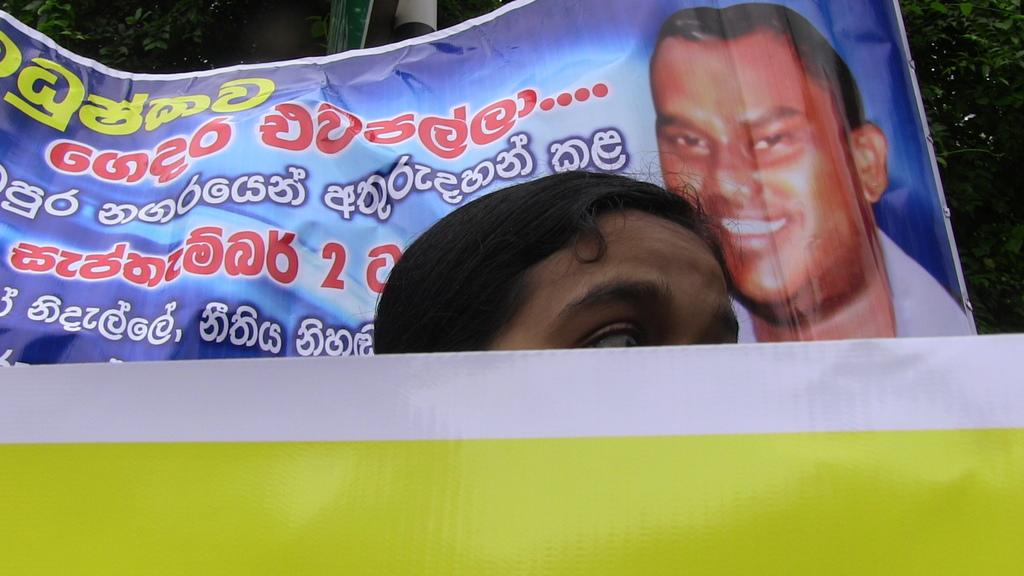What is the main subject of the image? There is a person's head in the center of the image. What is located at the bottom of the image? There is a banner at the bottom of the image. What can be seen in the background of the image? There is a flexi and trees present in the background of the image. How does the stranger rub the expansion in the image? There is no stranger or expansion present in the image. 